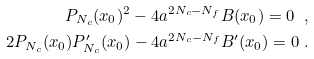Convert formula to latex. <formula><loc_0><loc_0><loc_500><loc_500>P _ { N _ { c } } ( x _ { 0 } ) ^ { 2 } - 4 \L a ^ { 2 N _ { c } - N _ { f } } B ( x _ { 0 } ) = 0 \ , \\ 2 P _ { N _ { c } } ( x _ { 0 } ) P ^ { \prime } _ { N _ { c } } ( x _ { 0 } ) - 4 \L a ^ { 2 N _ { c } - N _ { f } } B ^ { \prime } ( x _ { 0 } ) = 0 \ .</formula> 